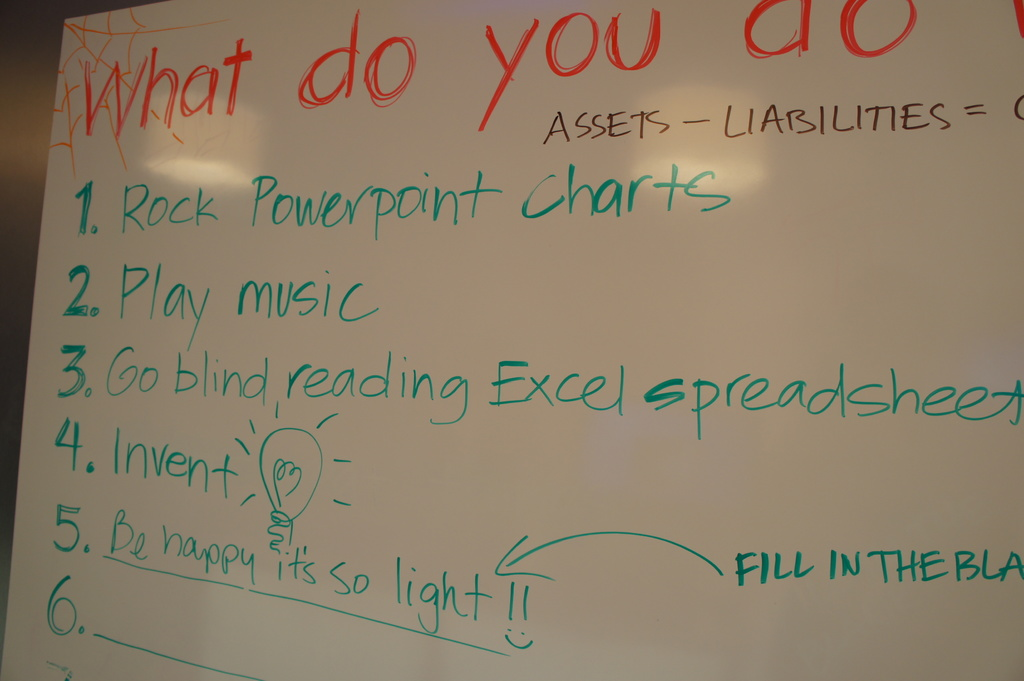Provide a one-sentence caption for the provided image. The image shows a whiteboard with a colorful list titled 'What do you do' featuring playful and creative activities like rocking PowerPoint charts, playing music, and inventing, encouraging joyful and imaginative engagement. 